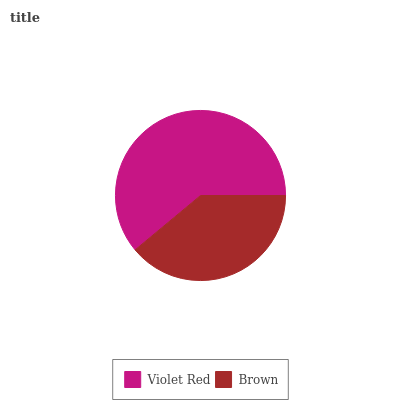Is Brown the minimum?
Answer yes or no. Yes. Is Violet Red the maximum?
Answer yes or no. Yes. Is Brown the maximum?
Answer yes or no. No. Is Violet Red greater than Brown?
Answer yes or no. Yes. Is Brown less than Violet Red?
Answer yes or no. Yes. Is Brown greater than Violet Red?
Answer yes or no. No. Is Violet Red less than Brown?
Answer yes or no. No. Is Violet Red the high median?
Answer yes or no. Yes. Is Brown the low median?
Answer yes or no. Yes. Is Brown the high median?
Answer yes or no. No. Is Violet Red the low median?
Answer yes or no. No. 